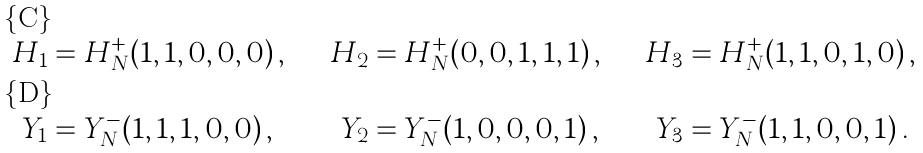<formula> <loc_0><loc_0><loc_500><loc_500>H _ { 1 } & = H ^ { + } _ { N } ( 1 , 1 , 0 , 0 , 0 ) \, , \quad & H _ { 2 } & = H ^ { + } _ { N } ( 0 , 0 , 1 , 1 , 1 ) \, , \quad & H _ { 3 } & = H ^ { + } _ { N } ( 1 , 1 , 0 , 1 , 0 ) \, , \\ Y _ { 1 } & = Y ^ { - } _ { N } ( 1 , 1 , 1 , 0 , 0 ) \, , \quad & Y _ { 2 } & = Y ^ { - } _ { N } ( 1 , 0 , 0 , 0 , 1 ) \, , \quad & Y _ { 3 } & = Y ^ { - } _ { N } ( 1 , 1 , 0 , 0 , 1 ) \, .</formula> 